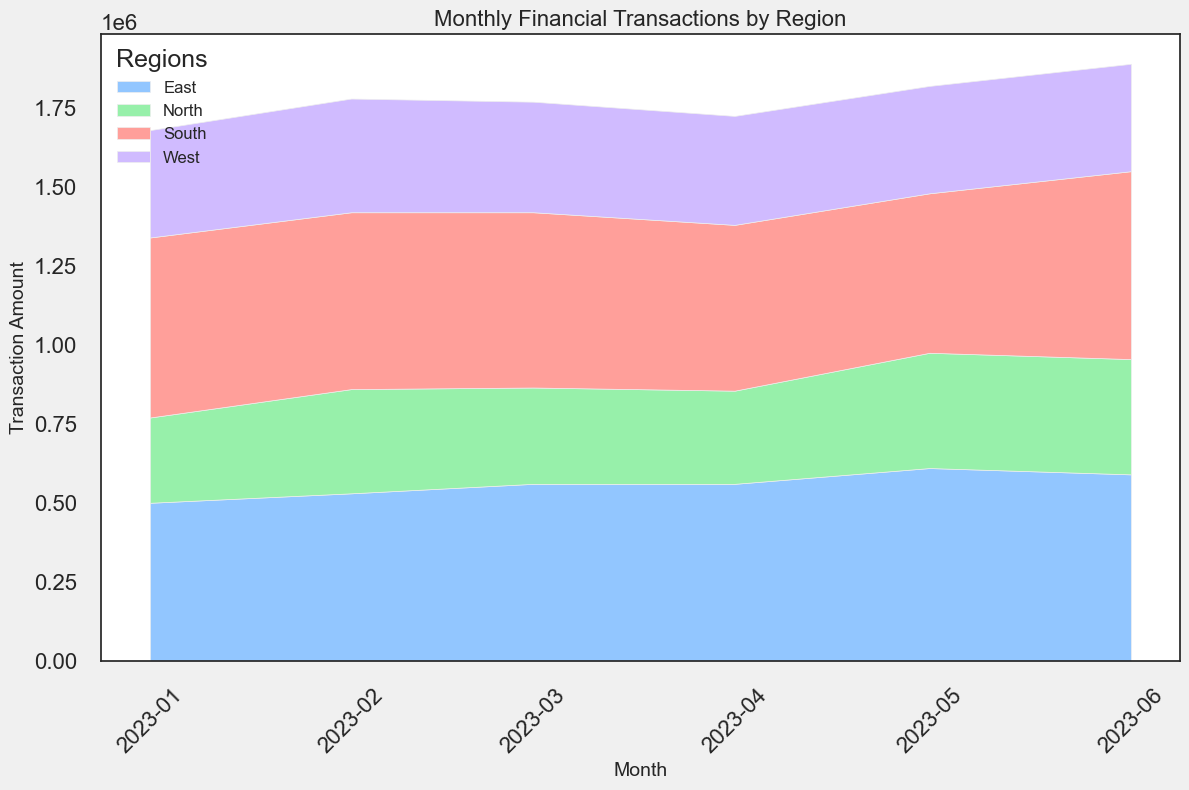Which region had the highest total transaction amount in May 2023? The May 2023 values for each region are: North (365000 + 145000 = 510000), East (370000 + 240000 = 610000), South (230000 + 275000 = 505000), West (150000 + 190000 = 340000). East has the highest value with 610,000.
Answer: East Which month saw the largest total transactions across all regions? Sum the transaction amounts for each month across all regions: 2023-01 (1220000), 2023-02 (1280000), 2023-03 (1270000), 2023-04 (1215000), 2023-05 (1230000), 2023-06 (1285000). The largest total transactions occurred in June 2023 with 1,285,000.
Answer: June 2023 Which region experienced the most significant increase from January to June 2023? Compare the changes from January to June for each region: North (510000 to 365000 + 155000 = 520000), East (500000 to 340000 + 250000 = 590000), South (570000 to 280000 + 315000 = 595000), West (340000 to 140000 + 200000 = 340000). South experienced the highest increase.
Answer: South Between March and April 2023, which individual had the largest decrease in transaction amount? Compare individual amounts between March and April: Individual_A (180000 to 160000, -20000), Individual_B (350000 to 330000, -20000), Individual_C (260000 to 240000, -20000), Individual_D (170000 to 160000, -10000), Individual_E (125000 to 135000, +10000), Individual_F (210000 to 230000, +20000), Individual_G (295000 to 285000, -10000), Individual_H (180000 to 185000, +5000). All of Individual_A, Individual_B, and Individual_C had the largest decrease of 20,000.
Answer: Individual_A, Individual_B, Individual_C Which region shows the least transaction volatility (i.e., smallest total change) from January to June 2023? Calculate the total change for each region: North (220000 - 150000 + 210000 - 200000 + 180000 - 160000 + 160000 - 180000 + 150000 - 160000 + 145000 - 120000), East (310000 - 300000 + 350000 - 310000 + 350000 - 220000 + 370000 - 330000 + 240000 - 200000 + 220000 - 110000 ), South (275000 - 270000 + 260000 - 250000 + 240000 - 260000 + 230000 - 295000 + 315000 - 275000), West (160000 - 180000 + 170000 - 160000 + 150000 - 140000 + 140000 - 150000 + 200000 - 180000 + 170000 - 160000). The least change is for the West Region.
Answer: West Which region had the highest transaction amount in a single month? The highest single monthly transaction amounts are North (220000), East (370000), South (315000), and West (200000). East had the highest with 370,000.
Answer: East What's the average monthly transaction amount for the East region in the first quarter of 2023? The amounts for the first quarter are 300000, 310000, and 350000. Sum these (300000 + 310000 + 350000 = 960000), then divide by 3. The average is 320,000.
Answer: 320000 